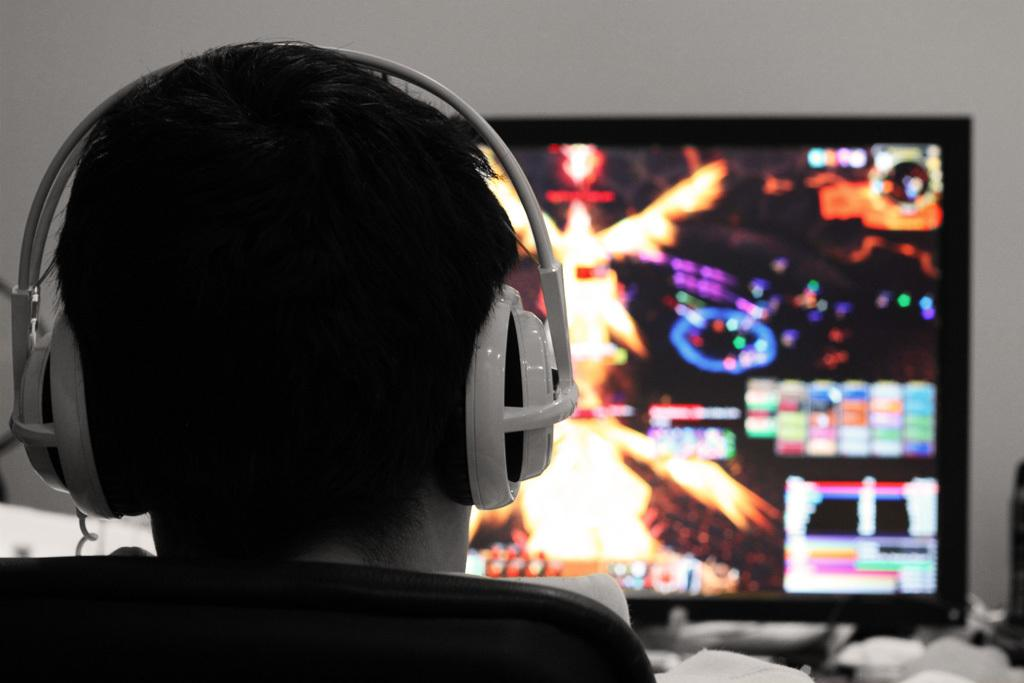What is the person in the image doing? The person is sitting on a chair. What can be seen on the person's head in the image? The person is wearing a headset. What is visible on the monitor in the image? There is a display on the monitor in the image. What is visible in the background of the image? There is a wall visible in the background. How many flocks of ice are present in the image? There are no flocks of ice present in the image. What hour is it in the image? The image does not provide any information about the time of day, so it is impossible to determine the hour. 